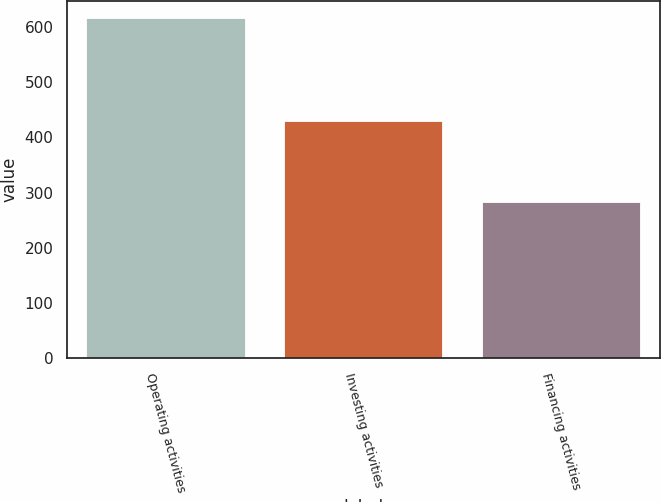<chart> <loc_0><loc_0><loc_500><loc_500><bar_chart><fcel>Operating activities<fcel>Investing activities<fcel>Financing activities<nl><fcel>616.2<fcel>429.3<fcel>283.4<nl></chart> 